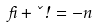<formula> <loc_0><loc_0><loc_500><loc_500>\beta + \kappa \omega = - n</formula> 